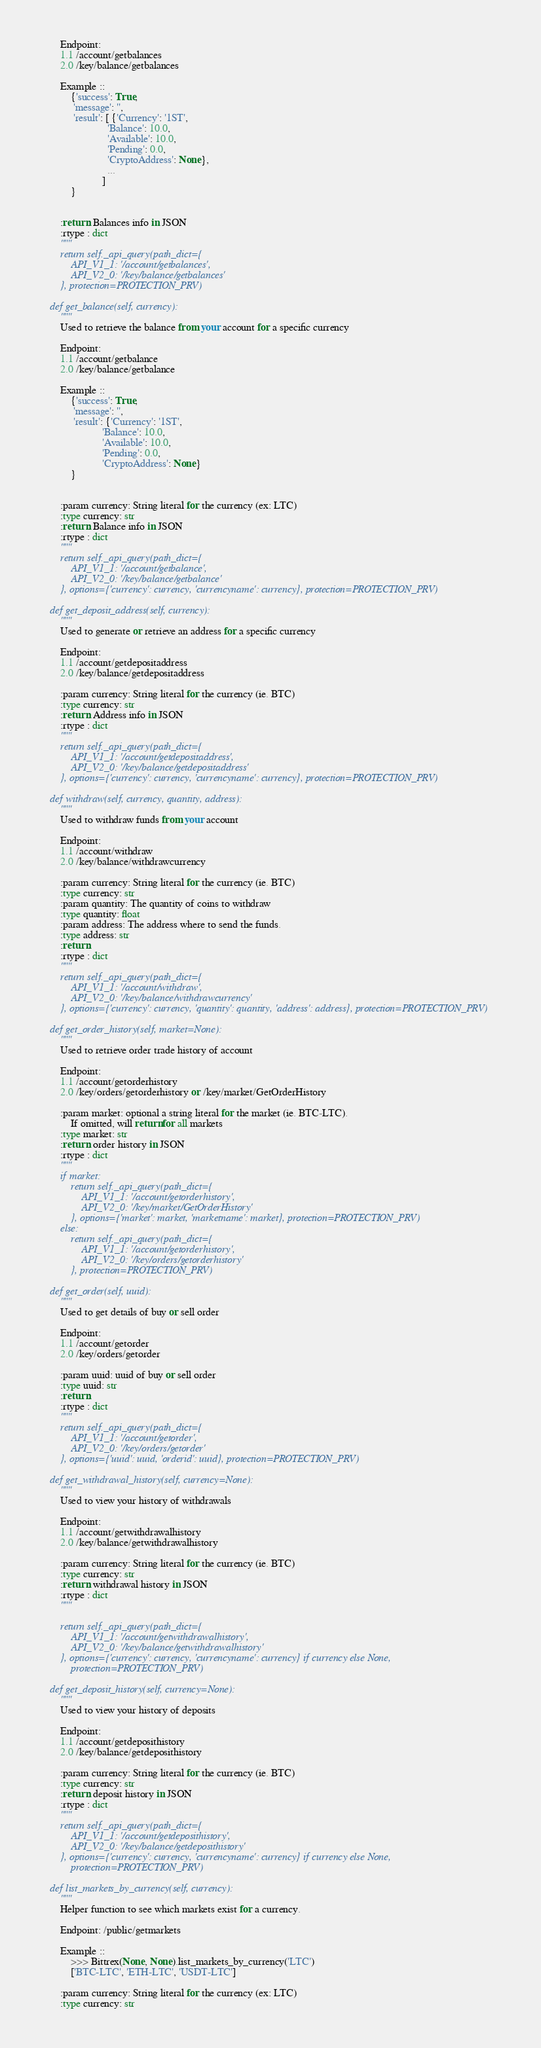Convert code to text. <code><loc_0><loc_0><loc_500><loc_500><_Python_>        Endpoint:
        1.1 /account/getbalances
        2.0 /key/balance/getbalances

        Example ::
            {'success': True,
             'message': '',
             'result': [ {'Currency': '1ST',
                          'Balance': 10.0,
                          'Available': 10.0,
                          'Pending': 0.0,
                          'CryptoAddress': None},
                          ...
                        ]
            }


        :return: Balances info in JSON
        :rtype : dict
        """
        return self._api_query(path_dict={
            API_V1_1: '/account/getbalances',
            API_V2_0: '/key/balance/getbalances'
        }, protection=PROTECTION_PRV)

    def get_balance(self, currency):
        """
        Used to retrieve the balance from your account for a specific currency

        Endpoint:
        1.1 /account/getbalance
        2.0 /key/balance/getbalance

        Example ::
            {'success': True,
             'message': '',
             'result': {'Currency': '1ST',
                        'Balance': 10.0,
                        'Available': 10.0,
                        'Pending': 0.0,
                        'CryptoAddress': None}
            }


        :param currency: String literal for the currency (ex: LTC)
        :type currency: str
        :return: Balance info in JSON
        :rtype : dict
        """
        return self._api_query(path_dict={
            API_V1_1: '/account/getbalance',
            API_V2_0: '/key/balance/getbalance'
        }, options={'currency': currency, 'currencyname': currency}, protection=PROTECTION_PRV)

    def get_deposit_address(self, currency):
        """
        Used to generate or retrieve an address for a specific currency

        Endpoint:
        1.1 /account/getdepositaddress
        2.0 /key/balance/getdepositaddress

        :param currency: String literal for the currency (ie. BTC)
        :type currency: str
        :return: Address info in JSON
        :rtype : dict
        """
        return self._api_query(path_dict={
            API_V1_1: '/account/getdepositaddress',
            API_V2_0: '/key/balance/getdepositaddress'
        }, options={'currency': currency, 'currencyname': currency}, protection=PROTECTION_PRV)

    def withdraw(self, currency, quantity, address):
        """
        Used to withdraw funds from your account

        Endpoint:
        1.1 /account/withdraw
        2.0 /key/balance/withdrawcurrency

        :param currency: String literal for the currency (ie. BTC)
        :type currency: str
        :param quantity: The quantity of coins to withdraw
        :type quantity: float
        :param address: The address where to send the funds.
        :type address: str
        :return:
        :rtype : dict
        """
        return self._api_query(path_dict={
            API_V1_1: '/account/withdraw',
            API_V2_0: '/key/balance/withdrawcurrency'
        }, options={'currency': currency, 'quantity': quantity, 'address': address}, protection=PROTECTION_PRV)

    def get_order_history(self, market=None):
        """
        Used to retrieve order trade history of account

        Endpoint:
        1.1 /account/getorderhistory
        2.0 /key/orders/getorderhistory or /key/market/GetOrderHistory

        :param market: optional a string literal for the market (ie. BTC-LTC).
            If omitted, will return for all markets
        :type market: str
        :return: order history in JSON
        :rtype : dict
        """
        if market:
            return self._api_query(path_dict={
                API_V1_1: '/account/getorderhistory',
                API_V2_0: '/key/market/GetOrderHistory'
            }, options={'market': market, 'marketname': market}, protection=PROTECTION_PRV)
        else:
            return self._api_query(path_dict={
                API_V1_1: '/account/getorderhistory',
                API_V2_0: '/key/orders/getorderhistory'
            }, protection=PROTECTION_PRV)

    def get_order(self, uuid):
        """
        Used to get details of buy or sell order

        Endpoint:
        1.1 /account/getorder
        2.0 /key/orders/getorder

        :param uuid: uuid of buy or sell order
        :type uuid: str
        :return:
        :rtype : dict
        """
        return self._api_query(path_dict={
            API_V1_1: '/account/getorder',
            API_V2_0: '/key/orders/getorder'
        }, options={'uuid': uuid, 'orderid': uuid}, protection=PROTECTION_PRV)

    def get_withdrawal_history(self, currency=None):
        """
        Used to view your history of withdrawals

        Endpoint:
        1.1 /account/getwithdrawalhistory
        2.0 /key/balance/getwithdrawalhistory

        :param currency: String literal for the currency (ie. BTC)
        :type currency: str
        :return: withdrawal history in JSON
        :rtype : dict
        """

        return self._api_query(path_dict={
            API_V1_1: '/account/getwithdrawalhistory',
            API_V2_0: '/key/balance/getwithdrawalhistory'
        }, options={'currency': currency, 'currencyname': currency} if currency else None,
            protection=PROTECTION_PRV)

    def get_deposit_history(self, currency=None):
        """
        Used to view your history of deposits

        Endpoint:
        1.1 /account/getdeposithistory
        2.0 /key/balance/getdeposithistory

        :param currency: String literal for the currency (ie. BTC)
        :type currency: str
        :return: deposit history in JSON
        :rtype : dict
        """
        return self._api_query(path_dict={
            API_V1_1: '/account/getdeposithistory',
            API_V2_0: '/key/balance/getdeposithistory'
        }, options={'currency': currency, 'currencyname': currency} if currency else None,
            protection=PROTECTION_PRV)

    def list_markets_by_currency(self, currency):
        """
        Helper function to see which markets exist for a currency.

        Endpoint: /public/getmarkets

        Example ::
            >>> Bittrex(None, None).list_markets_by_currency('LTC')
            ['BTC-LTC', 'ETH-LTC', 'USDT-LTC']

        :param currency: String literal for the currency (ex: LTC)
        :type currency: str</code> 